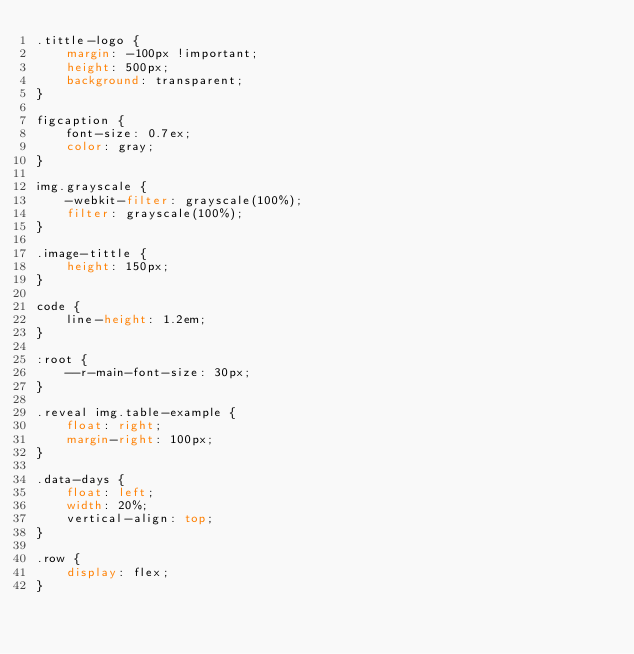Convert code to text. <code><loc_0><loc_0><loc_500><loc_500><_CSS_>.tittle-logo {
    margin: -100px !important;
    height: 500px;
    background: transparent;
}

figcaption {
    font-size: 0.7ex;
    color: gray;
}

img.grayscale {
    -webkit-filter: grayscale(100%);
    filter: grayscale(100%);
}

.image-tittle {
    height: 150px;
}

code {
    line-height: 1.2em;
}

:root {
    --r-main-font-size: 30px;
}

.reveal img.table-example {
    float: right;
    margin-right: 100px;
}

.data-days {
    float: left;
    width: 20%;
    vertical-align: top;
}

.row {
    display: flex;
}</code> 